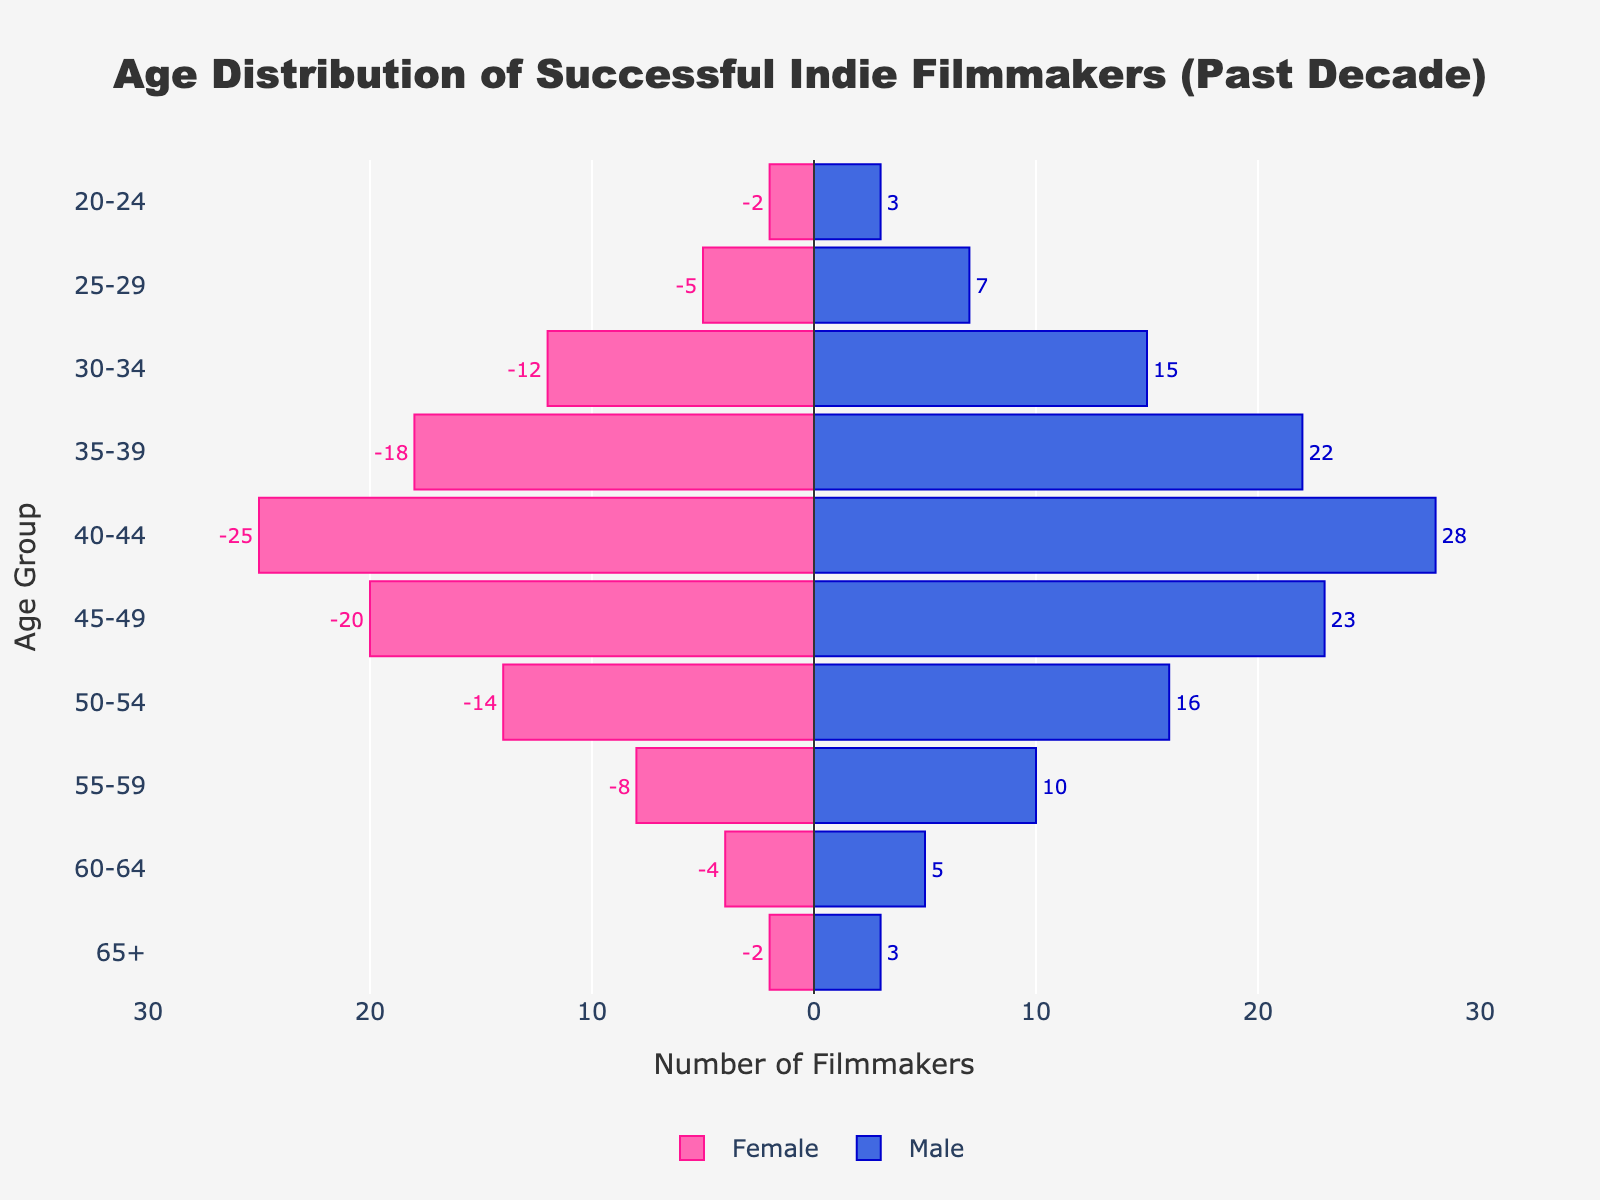What is the color used to represent females on the plot? By looking at the plot, the female section of the population pyramid is represented in pink color.
Answer: Pink How many age groups are displayed in the plot? The plot displays the following age groups: 20-24, 25-29, 30-34, 35-39, 40-44, 45-49, 50-54, 55-59, 60-64, and 65+. Counting them gives a total of 10 age groups.
Answer: 10 Which age group has the highest number of male filmmakers? By examining the plot, the age group 40-44 has the highest number of male filmmakers, with 28 males.
Answer: 40-44 What is the total number of female filmmakers in the age group 30-34? The plot shows that there are 12 female filmmakers in the 30-34 age group.
Answer: 12 Compare the number of male and female filmmakers in the age group 45-49. Which gender has more filmmakers? The plot shows that in the age group 45-49, there are 23 male filmmakers and 20 female filmmakers, meaning males have more filmmakers.
Answer: Males What is the sum of male and female filmmakers in the age group 50-54? The plot shows 16 male and 14 female filmmakers in the 50-54 age group. Summing them gives 16 + 14 = 30.
Answer: 30 Identify the age group with the smallest number of filmmakers for both genders combined. By comparing the numbers across all age groups in the plot, the age group 20-24 has the smallest total (2 females and 3 males, summing to 5).
Answer: 20-24 How does the number of male filmmakers compare with female filmmakers in the age group 35-39? The plot shows that there are 22 male filmmakers compared to 18 female filmmakers in the 35-39 age group, indicating more males than females.
Answer: Males What is the difference in the number of filmmakers between the age groups 25-29 and 55-59 for both genders combined? The sum of filmmakers in the age group 25-29 is 5 females + 7 males = 12. The sum for the age group 55-59 is 8 females + 10 males = 18. The difference is 18 - 12 = 6.
Answer: 6 What percentage of the total number of filmmakers does the age group 40-44 represent for each gender? For females in the 40-44 age group: (25 females / total 110 females) * 100 ≈ 22.73%. For males: (28 males / total 132 males) * 100 ≈ 21.21%.
Answer: 22.73% females, 21.21% males 